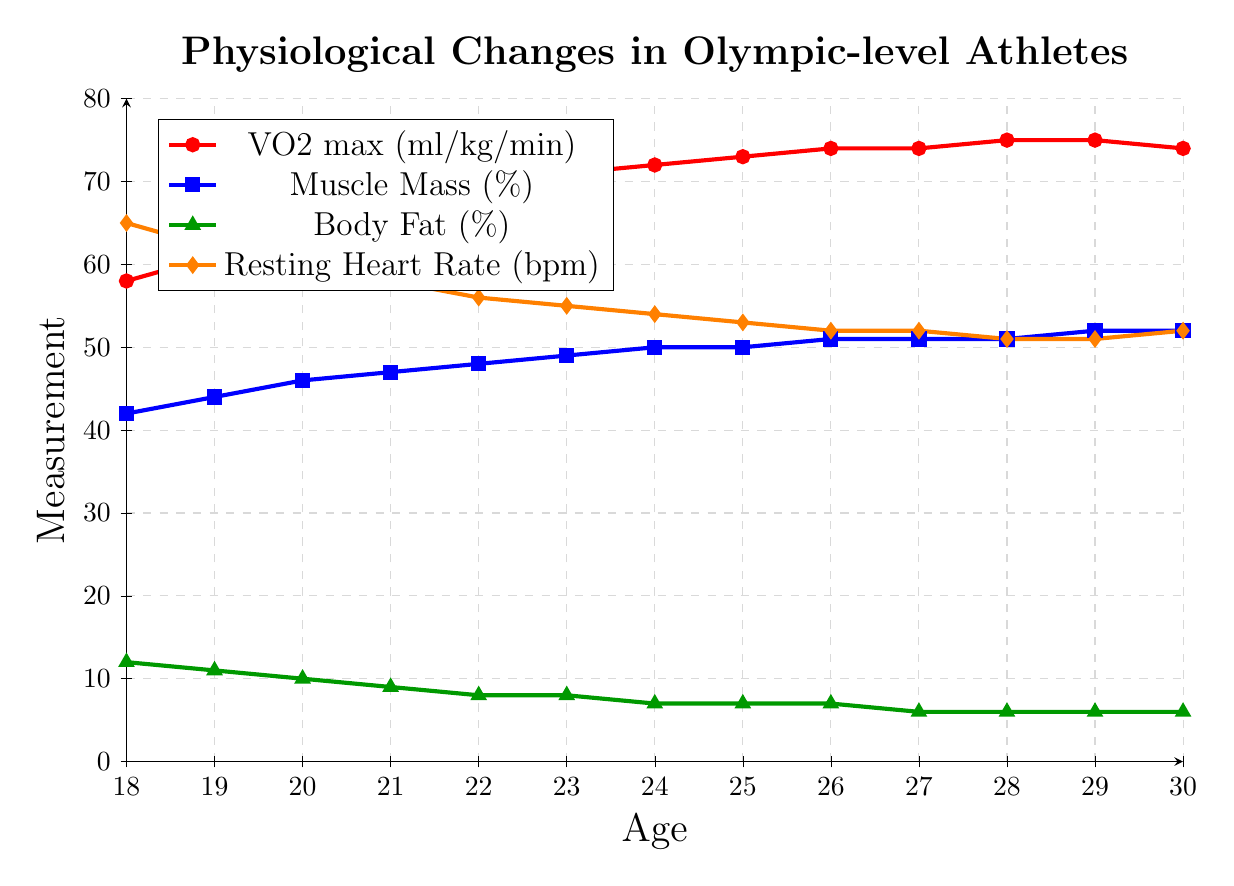How does the VO2 max change from age 18 to age 20? To determine the change in VO2 max, look at the values at age 18 (58 ml/kg/min) and age 20 (64 ml/kg/min). Subtract the initial value from the later value: 64 - 58 = 6 ml/kg/min.
Answer: 6 ml/kg/min Which variable has the visually steadiest (most consistent) increase over the ages observed? By examining the figure, Muscle Mass shows a relatively straight and consistent increase each year compared to VO2 max and Body Fat.
Answer: Muscle Mass Between ages 22 and 24, how much does the body fat percentage decrease? Locate the Body Fat percentage at age 22 (8%) and age 24 (7%). Subtract the later value from the initial value: 8 - 7 = 1%.
Answer: 1% At which age does the Resting Heart Rate reach its lowest value? Observe the plot for Resting Heart Rate and find the minimum point, which occurs at age 28 and 29 with a value of 51 bpm.
Answer: 28 How does Muscle Mass (%) change from age 18 to age 30? Compare Muscle Mass at age 18 (42%) to age 30 (52%). The difference is 52 - 42 = 10%.
Answer: 10% Is there a point where the VO2 max and Muscle Mass have the same trend? By examining the lines representing VO2 max and Muscle Mass, you can see that both increase steadily over the years, but they don't overlap or have the same value at any point. However, their trend is consistently upward until around age 28-30.
Answer: Upward trend until around age 28-30 What is the average Resting Heart Rate between ages 21 and 25? Identify the Resting Heart Rate values for ages 21 (58 bpm), 22 (56 bpm), 23 (55 bpm), 24 (54 bpm), and 25 (53 bpm). Sum these values and divide by 5: (58 + 56 + 55 + 54 + 53) / 5 = 276 / 5 = 55.2 bpm.
Answer: 55.2 bpm What is the difference in Body Fat percentage between the ages with the highest and lowest values? Identify the highest value at age 18 (12%) and the lowest value at ages 27-30 (6%). The difference is 12 - 6 = 6%.
Answer: 6% At what age does Muscle Mass first reach 50%? Observe the Muscle Mass plot and find the first age where the value reaches 50%, which is at age 24.
Answer: 24 